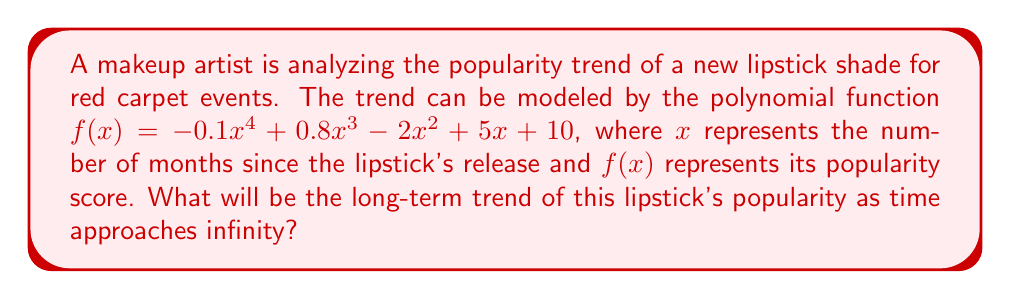Teach me how to tackle this problem. To determine the long-term trend of the lipstick's popularity, we need to analyze the end behavior of the given polynomial function.

Step 1: Identify the leading term
The leading term of $f(x) = -0.1x^4 + 0.8x^3 - 2x^2 + 5x + 10$ is $-0.1x^4$.

Step 2: Determine the degree and leading coefficient
- Degree: 4 (even)
- Leading coefficient: -0.1 (negative)

Step 3: Analyze the end behavior
For polynomials with even degree:
- If the leading coefficient is positive, both ends of the graph go up as x approaches ±∞.
- If the leading coefficient is negative, both ends of the graph go down as x approaches ±∞.

In this case, since the degree is even (4) and the leading coefficient is negative (-0.1), both ends of the graph will go down as x approaches ±∞.

Step 4: Interpret the result
As time (x) approaches infinity, the popularity score f(x) will decrease without bound. This means the lipstick's popularity will decline in the long term.
Answer: The lipstick's popularity will decline as time approaches infinity. 